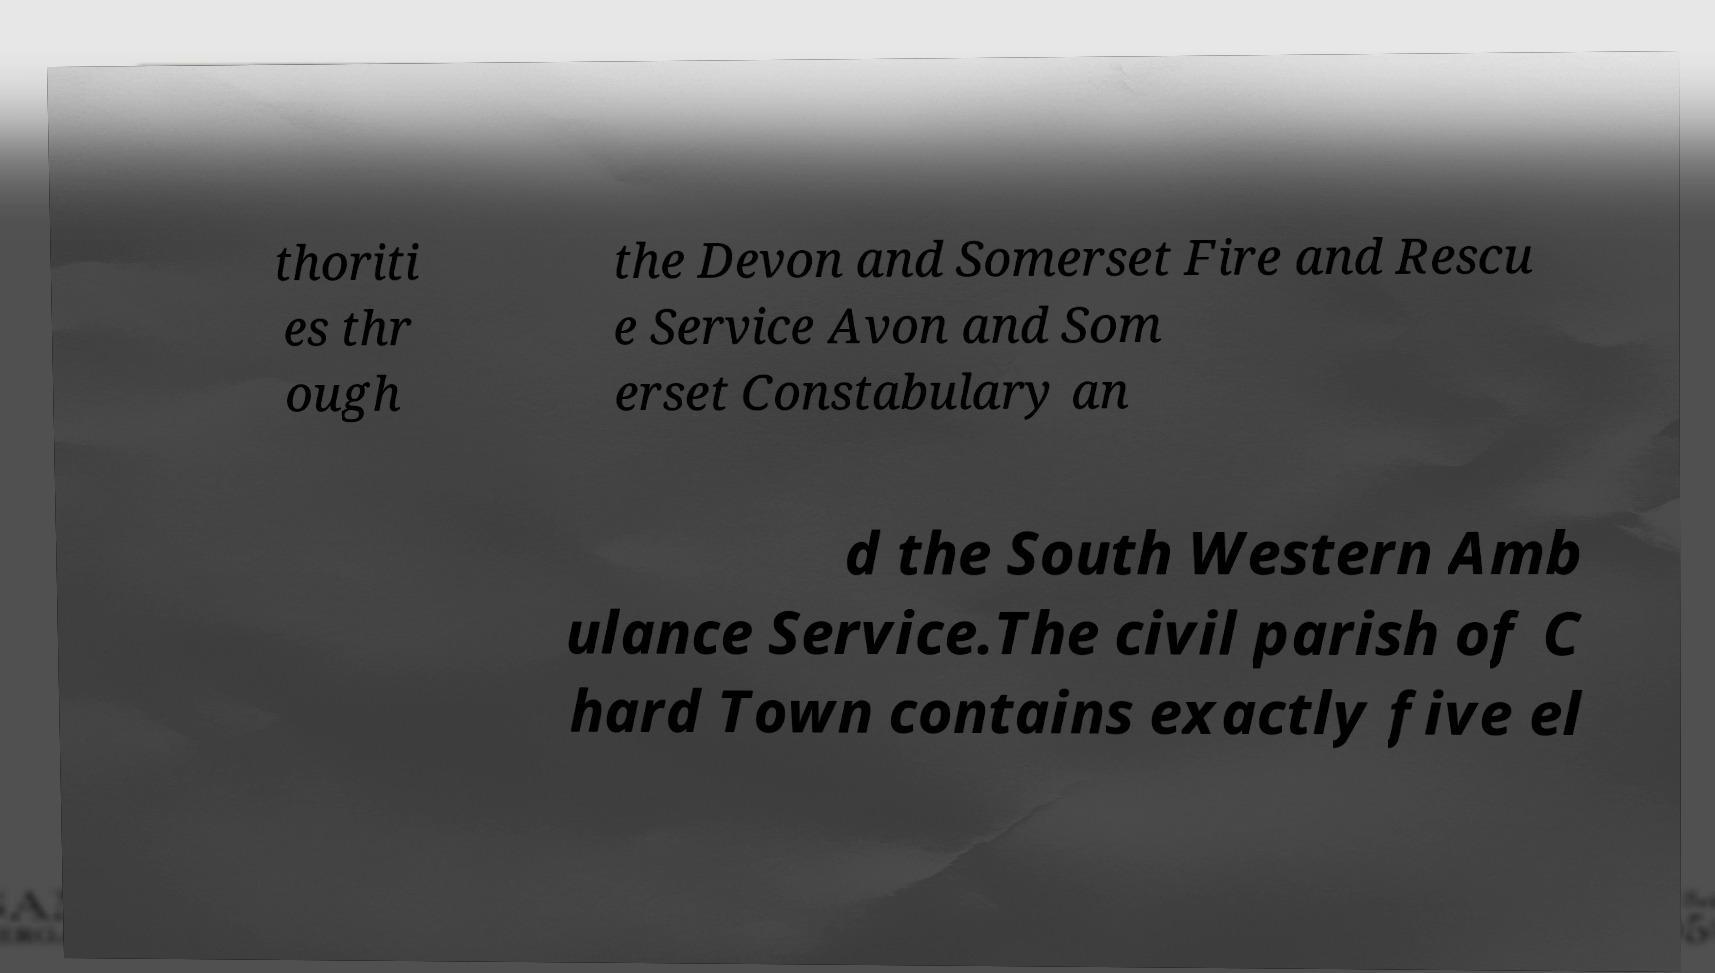I need the written content from this picture converted into text. Can you do that? thoriti es thr ough the Devon and Somerset Fire and Rescu e Service Avon and Som erset Constabulary an d the South Western Amb ulance Service.The civil parish of C hard Town contains exactly five el 